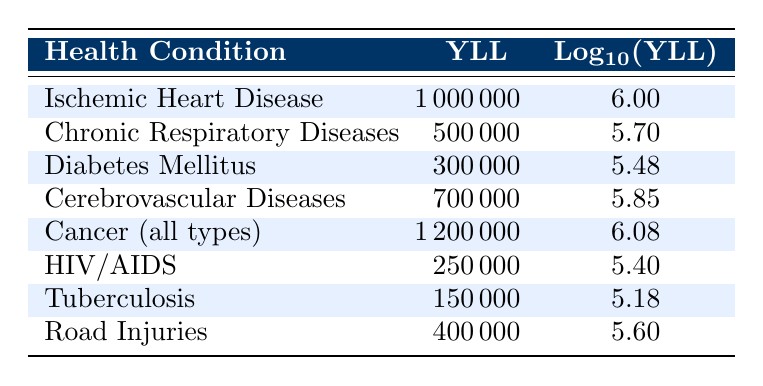What is the Year of Life Lost (YLL) due to Cancer? The table lists Cancer (all types) with a corresponding YLL value of 1,200,000.
Answer: 1,200,000 Which health condition has the highest YLL value? From the table, Cancer (all types) has the highest YLL value of 1,200,000.
Answer: Cancer (all types) What is the YLL for Diabetes Mellitus? The YLL value for Diabetes Mellitus is specifically listed in the table as 300,000.
Answer: 300,000 Is the YLL for Chronic Respiratory Diseases greater than that for Tuberculosis? The table shows Chronic Respiratory Diseases with a YLL of 500,000 and Tuberculosis with 150,000, so 500,000 is greater than 150,000, making the statement true.
Answer: Yes What is the sum of YLL for Road Injuries and HIV/AIDS? The YLL for Road Injuries is 400,000 and for HIV/AIDS is 250,000. Summing these gives 400,000 + 250,000 = 650,000.
Answer: 650,000 What is the average YLL for all conditions listed? To find the average, we add all YLL values: 1,000,000 + 500,000 + 300,000 + 700,000 + 1,200,000 + 250,000 + 150,000 + 400,000 = 4,500,000. Then, divide by the count of conditions (8), yielding an average of 4,500,000 / 8 = 562,500.
Answer: 562,500 Does the YLL value for Ischemic Heart Disease exceed 900,000? The table shows a YLL of 1,000,000 for Ischemic Heart Disease, which clearly exceeds 900,000, making the statement true.
Answer: Yes Which two conditions combined have a YLL closest to 1,000,000? Evaluating combinations, Ischemic Heart Disease (1,000,000) or Cancer (1,200,000) alone exceed 1,000,000. However, combining the next highest, Cerebrovascular Diseases (700,000) with Chronic Respiratory Diseases (500,000) gives 1,200,000, which is also excessive. Thus, not directly applicable but noteworthy that no combination reaches closest than 1,000,000 without overriding.
Answer: None 